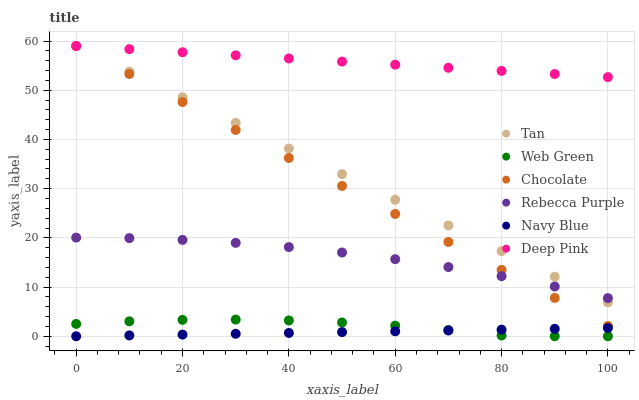Does Navy Blue have the minimum area under the curve?
Answer yes or no. Yes. Does Deep Pink have the maximum area under the curve?
Answer yes or no. Yes. Does Web Green have the minimum area under the curve?
Answer yes or no. No. Does Web Green have the maximum area under the curve?
Answer yes or no. No. Is Navy Blue the smoothest?
Answer yes or no. Yes. Is Web Green the roughest?
Answer yes or no. Yes. Is Web Green the smoothest?
Answer yes or no. No. Is Navy Blue the roughest?
Answer yes or no. No. Does Navy Blue have the lowest value?
Answer yes or no. Yes. Does Chocolate have the lowest value?
Answer yes or no. No. Does Tan have the highest value?
Answer yes or no. Yes. Does Web Green have the highest value?
Answer yes or no. No. Is Navy Blue less than Rebecca Purple?
Answer yes or no. Yes. Is Rebecca Purple greater than Web Green?
Answer yes or no. Yes. Does Navy Blue intersect Web Green?
Answer yes or no. Yes. Is Navy Blue less than Web Green?
Answer yes or no. No. Is Navy Blue greater than Web Green?
Answer yes or no. No. Does Navy Blue intersect Rebecca Purple?
Answer yes or no. No. 